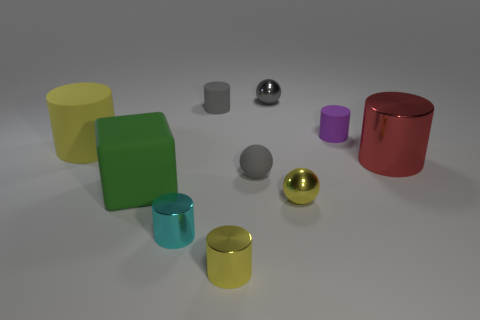How many big green things are the same shape as the large red thing?
Provide a succinct answer. 0. What material is the red object?
Provide a succinct answer. Metal. Are there the same number of big red cylinders that are behind the big yellow cylinder and tiny metallic cylinders?
Give a very brief answer. No. There is a green thing that is the same size as the red metal thing; what shape is it?
Keep it short and to the point. Cube. Are there any tiny shiny cylinders that are behind the big rubber object to the right of the yellow rubber object?
Provide a short and direct response. No. What number of large things are either shiny cylinders or gray cylinders?
Give a very brief answer. 1. Are there any yellow metal objects of the same size as the red cylinder?
Your answer should be compact. No. How many matte objects are large things or small cyan cylinders?
Make the answer very short. 2. What shape is the matte object that is the same color as the small matte ball?
Your response must be concise. Cylinder. What number of gray cylinders are there?
Offer a very short reply. 1. 